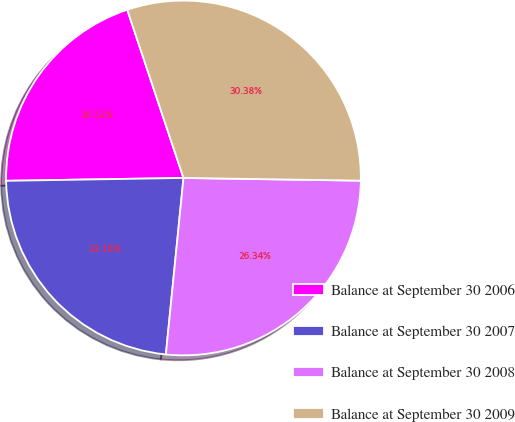Convert chart to OTSL. <chart><loc_0><loc_0><loc_500><loc_500><pie_chart><fcel>Balance at September 30 2006<fcel>Balance at September 30 2007<fcel>Balance at September 30 2008<fcel>Balance at September 30 2009<nl><fcel>20.12%<fcel>23.16%<fcel>26.34%<fcel>30.38%<nl></chart> 